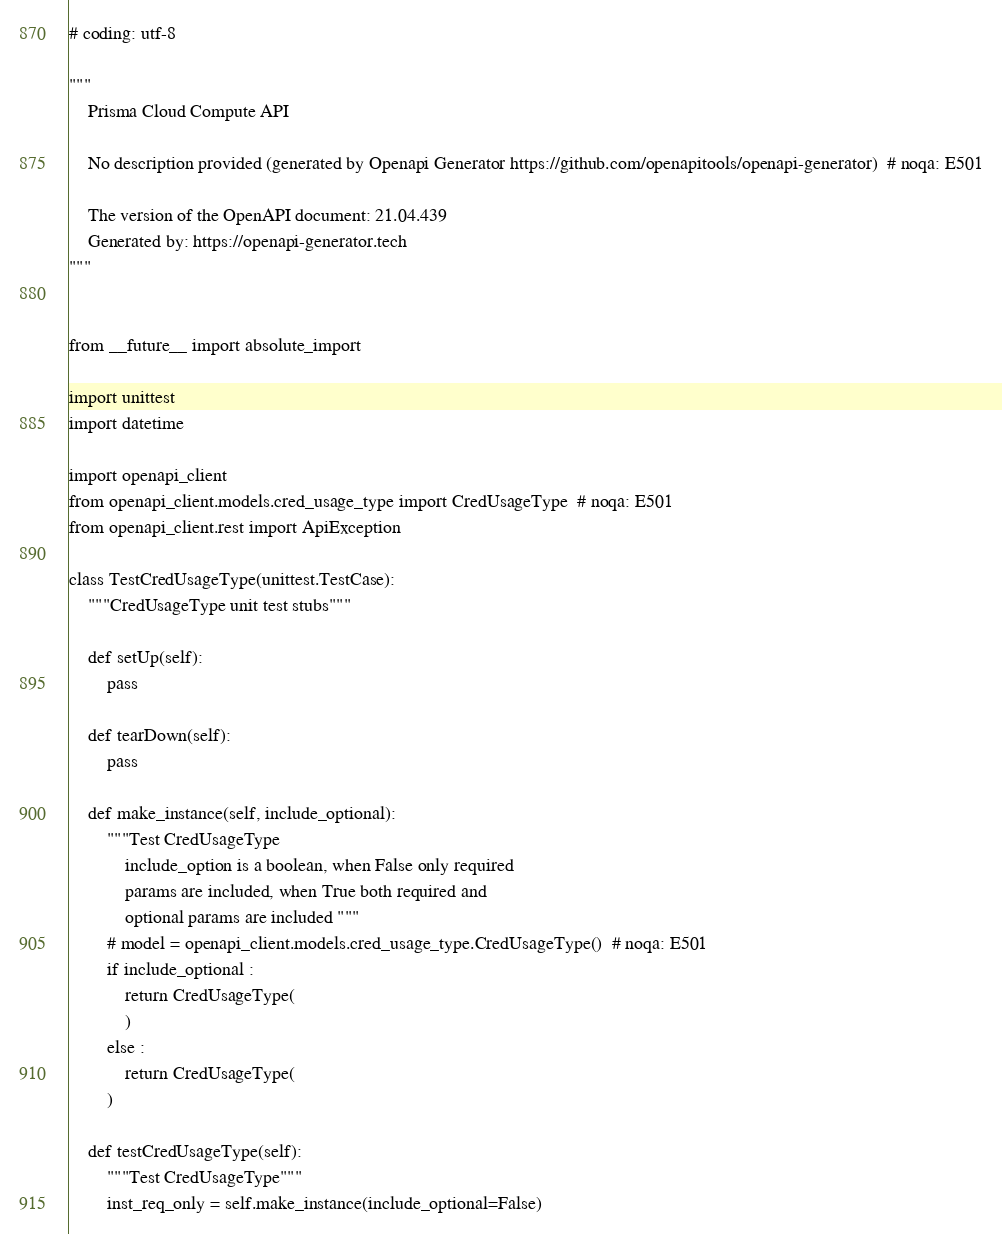Convert code to text. <code><loc_0><loc_0><loc_500><loc_500><_Python_># coding: utf-8

"""
    Prisma Cloud Compute API

    No description provided (generated by Openapi Generator https://github.com/openapitools/openapi-generator)  # noqa: E501

    The version of the OpenAPI document: 21.04.439
    Generated by: https://openapi-generator.tech
"""


from __future__ import absolute_import

import unittest
import datetime

import openapi_client
from openapi_client.models.cred_usage_type import CredUsageType  # noqa: E501
from openapi_client.rest import ApiException

class TestCredUsageType(unittest.TestCase):
    """CredUsageType unit test stubs"""

    def setUp(self):
        pass

    def tearDown(self):
        pass

    def make_instance(self, include_optional):
        """Test CredUsageType
            include_option is a boolean, when False only required
            params are included, when True both required and
            optional params are included """
        # model = openapi_client.models.cred_usage_type.CredUsageType()  # noqa: E501
        if include_optional :
            return CredUsageType(
            )
        else :
            return CredUsageType(
        )

    def testCredUsageType(self):
        """Test CredUsageType"""
        inst_req_only = self.make_instance(include_optional=False)</code> 